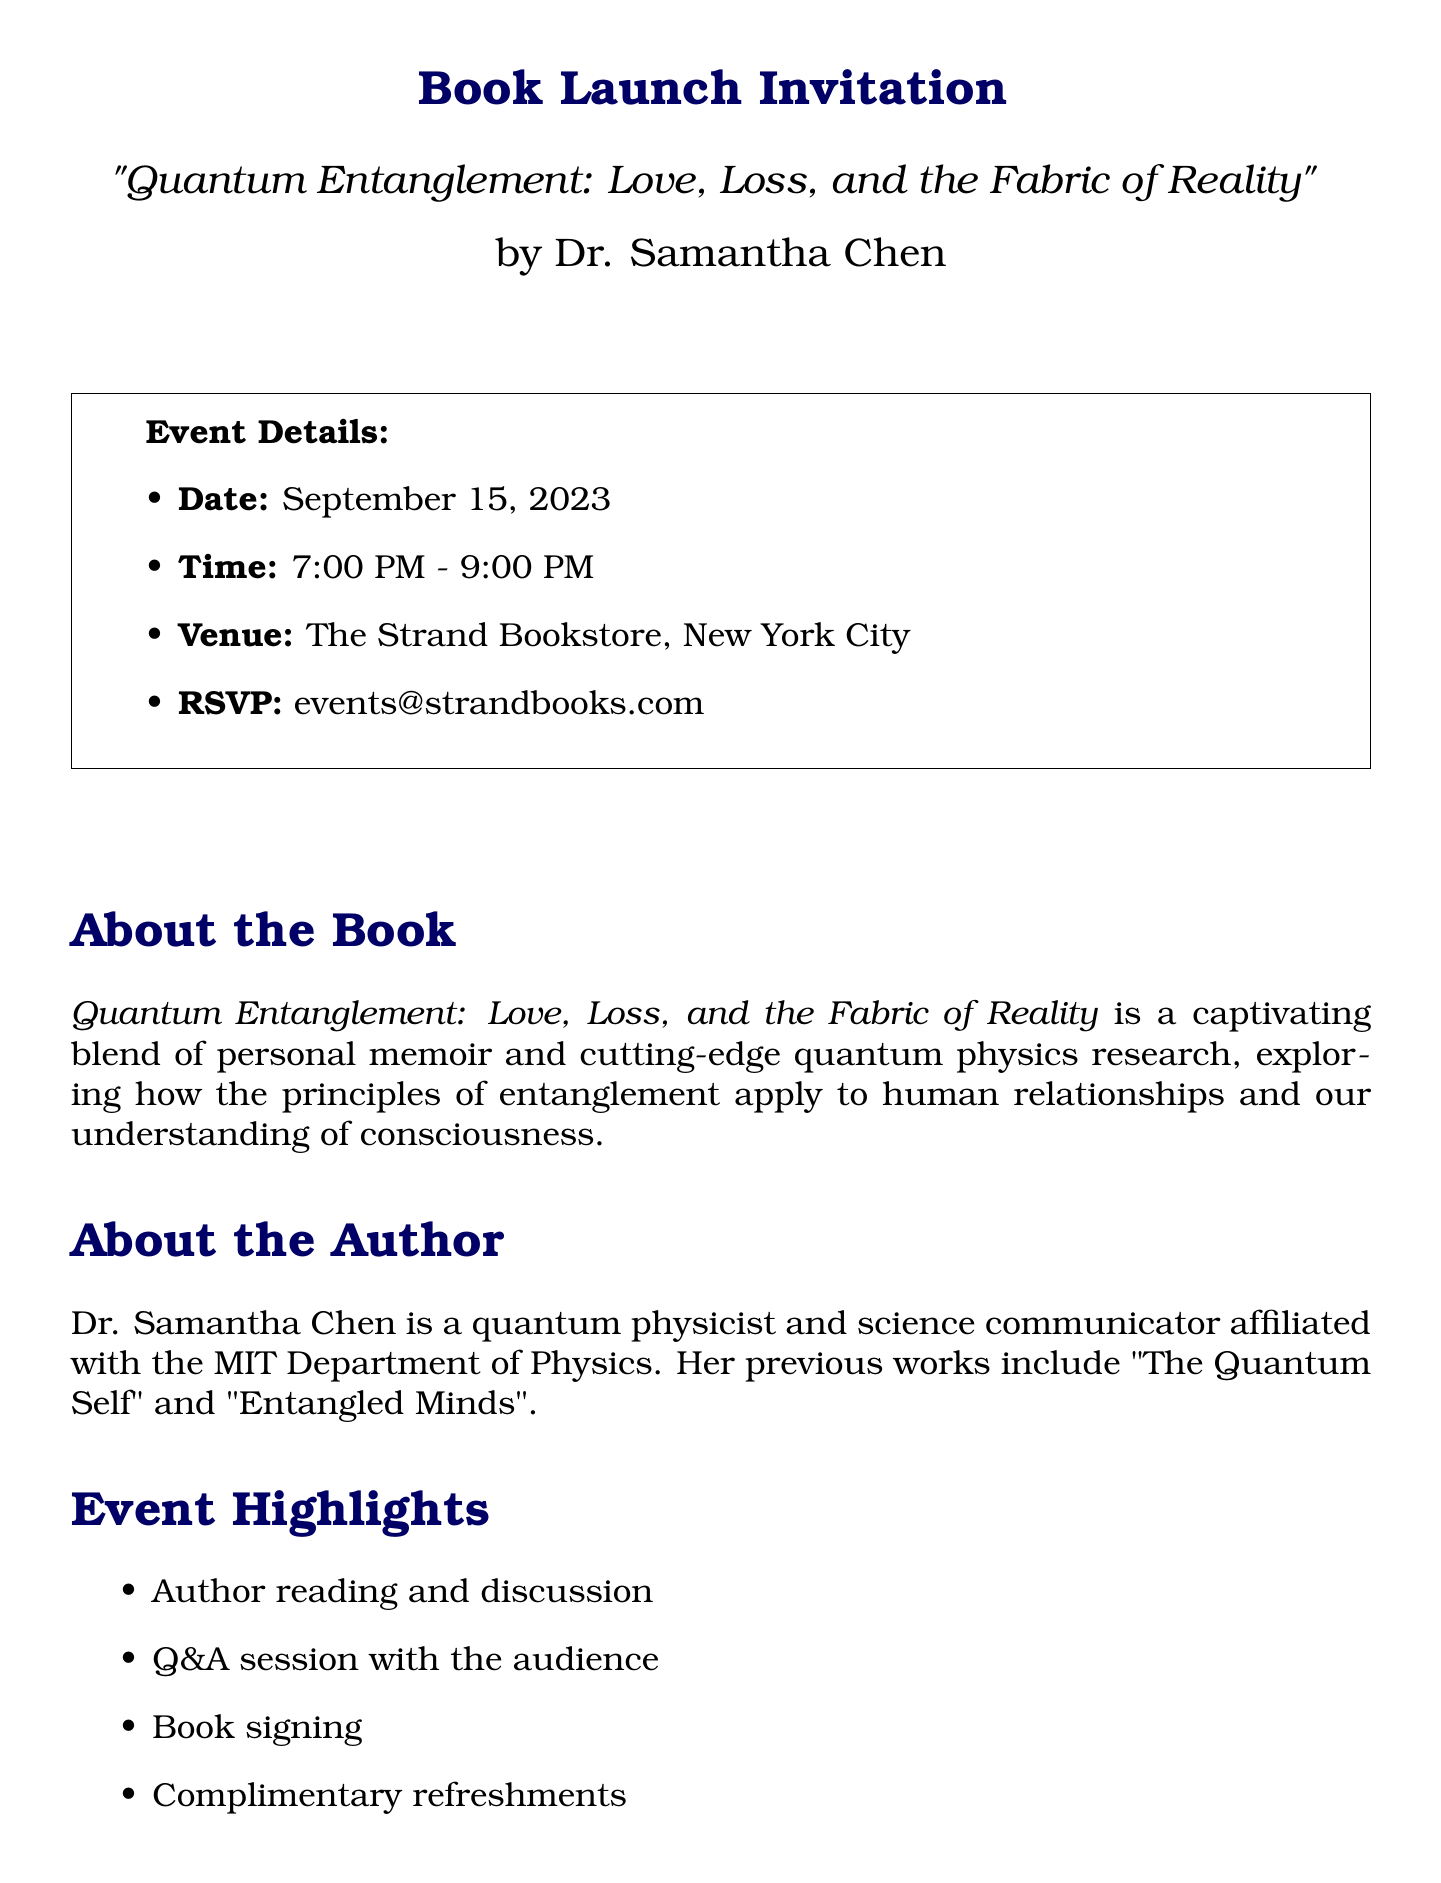What is the book title? The title of the book is mentioned clearly in the invitation section.
Answer: Quantum Entanglement: Love, Loss, and the Fabric of Reality Who is the author? The author’s name is provided in the introduction of the book launch.
Answer: Dr. Samantha Chen What is the date of the event? The specific date of the book launch is listed under event details.
Answer: September 15, 2023 Where is the venue located? The venue for the event is specified in the event details section of the document.
Answer: The Strand Bookstore, New York City What is one theme of personal stories included in the book? A list of personal story themes is given which can be referenced for this information.
Answer: Loss of a loved one and its connection to quantum mechanics What scientific topic is covered in the book? The document lists several scientific topics that are covered in the book.
Answer: Quantum entanglement How long is the event scheduled to last? The time frame for the book launch event is provided clearly in the event details.
Answer: 2 hours What type of refreshments will be available? The document specifies refreshments as part of the event highlights.
Answer: Complimentary refreshments What is a unique opportunity mentioned in the invitation? The invitation highlights the chance to engage with a specific aspect of the event.
Answer: Engage with Dr. Chen's groundbreaking work 